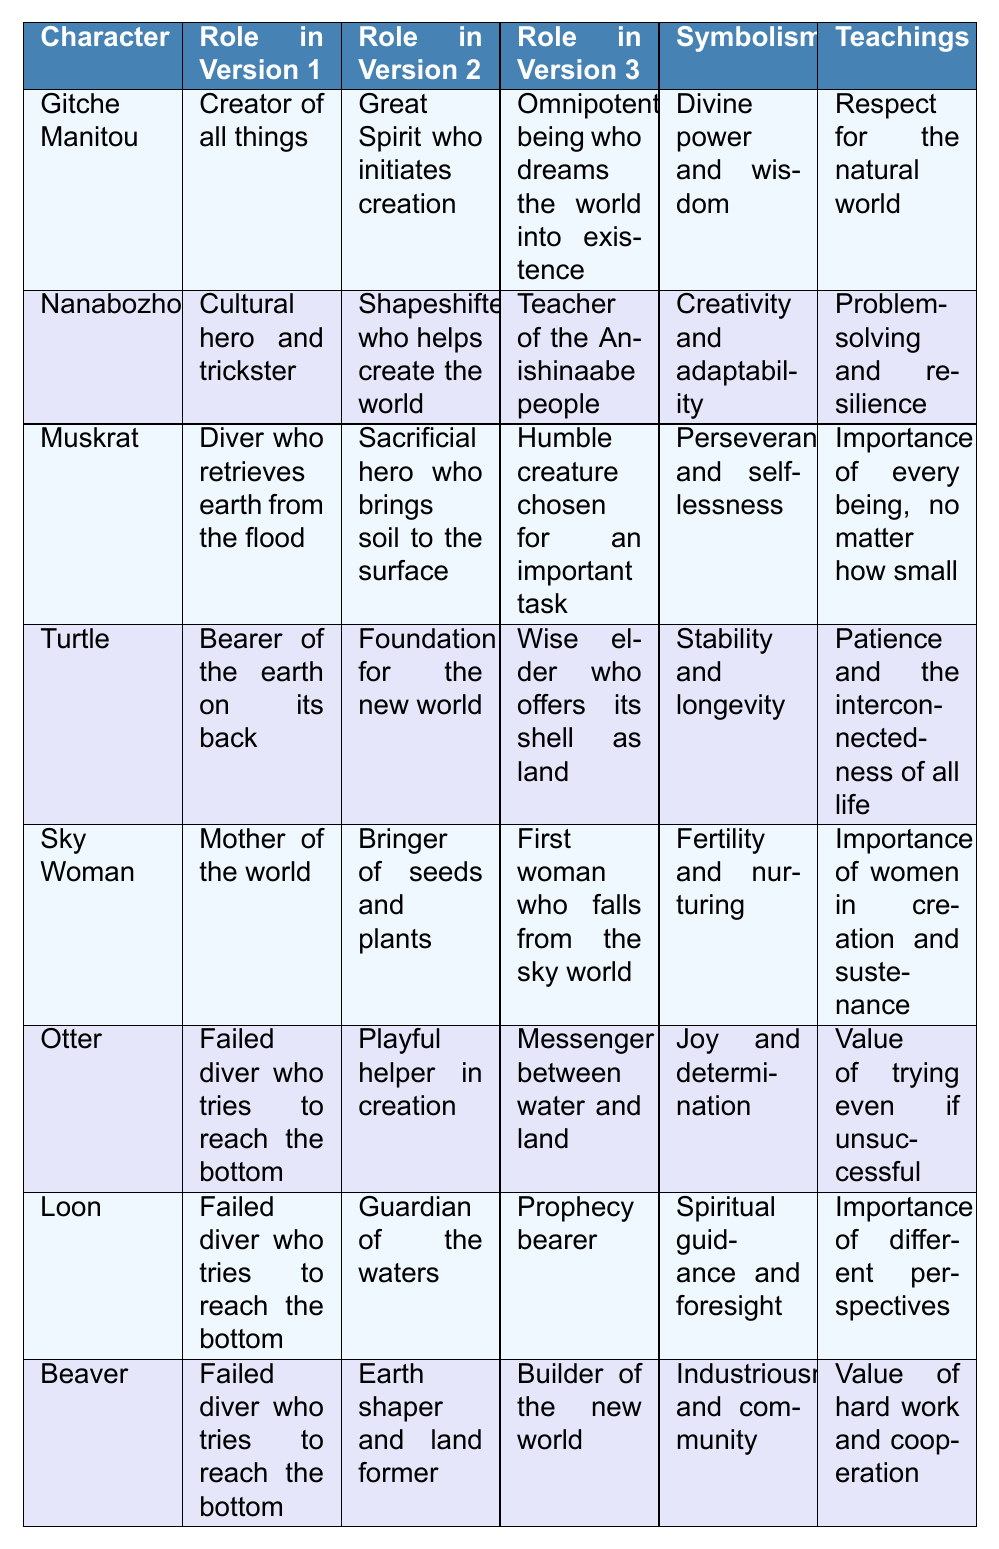What is the role of Gitche Manitou in version 2? According to the table, Gitche Manitou's role in version 2 is described as a "Great Spirit who initiates creation."
Answer: Great Spirit who initiates creation What teachings are attributed to Turtle? The table states that Turtle's teachings focus on "Patience and the interconnectedness of all life."
Answer: Patience and the interconnectedness of all life Which character symbolizes "Creativity and adaptability"? By checking the table, it is clear that Nanabozho symbolizes "Creativity and adaptability."
Answer: Nanabozho How many characters serve as failed divers in all versions? The table lists three characters (Otter, Loon, Beaver) that have the same role of "Failed diver who tries to reach the bottom" in version 1.
Answer: Three characters Do both Muskrat and Beaver have roles related to creation in version 2? Yes, both Muskrat (sacrificial hero who brings soil to the surface) and Beaver (earth shaper and land former) have roles that are directly related to creation in version 2.
Answer: Yes Which character teaches about the importance of trying despite failures? The table indicates that Otter teaches the "Value of trying even if unsuccessful."
Answer: Otter How is the symbolism of Sky Woman related to her role in the creation story? Sky Woman symbolizes "Fertility and nurturing," reflecting her role as the "Mother of the world" and the one who brings seeds and plants, indicating her contribution to life and sustenance.
Answer: Fertility and nurturing Which character plays a role as a teacher and what is their symbolism? Nanabozho serves as a "Teacher of the Anishinaabe people" and symbolizes "Creativity and adaptability."
Answer: Nanabozho; Creativity and adaptability How does the teaching of Muskrat contrast with that of Beaver? Muskrat teaches the "Importance of every being, no matter how small," while Beaver emphasizes the "Value of hard work and cooperation," highlighting different aspects of life and community.
Answer: Different aspects of life and community In the roles across the versions, who demonstrates continuity as a stable foundation? According to the table, Turtle consistently provides stability in all versions, as seen in his roles including "Bearer of the earth on its back" and "Foundation for the new world."
Answer: Turtle How do the roles of Otter and Loon differ in terms of their contributions to the creation narrative? Otter is described as a "Playful helper in creation," while Loon serves as the "Guardian of the waters." Their contributions reflect different strengths: Otter's playfulness and Loon's responsibility over waters.
Answer: They have different strengths in the narrative 